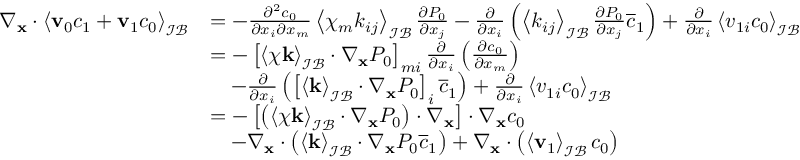<formula> <loc_0><loc_0><loc_500><loc_500>\begin{array} { r l } { \nabla _ { \mathbf x } \cdot \left \langle \mathbf v _ { 0 } c _ { 1 } + \mathbf v _ { 1 } c _ { 0 } \right \rangle _ { \mathcal { I B } } } & { = - \frac { \partial ^ { 2 } c _ { 0 } } { \partial x _ { i } \partial x _ { m } } \left \langle \chi _ { m } k _ { i j } \right \rangle _ { \mathcal { I B } } \frac { \partial P _ { 0 } } { \partial x _ { j } } - \frac { \partial } { \partial x _ { i } } \left ( \left \langle k _ { i j } \right \rangle _ { \mathcal { I B } } \frac { \partial P _ { 0 } } { \partial x _ { j } } \overline { c } _ { 1 } \right ) + \frac { \partial } { \partial x _ { i } } \left \langle v _ { 1 i } c _ { 0 } \right \rangle _ { \mathcal { I B } } } \\ & { = - \left [ \left \langle \boldsymbol \chi \mathbf k \right \rangle _ { \mathcal { I B } } \cdot \nabla _ { \mathbf x } P _ { 0 } \right ] _ { m i } \frac { \partial } { \partial x _ { i } } \left ( \frac { \partial c _ { 0 } } { \partial x _ { m } } \right ) } \\ & { \quad - \frac { \partial } { \partial x _ { i } } \left ( \left [ \left \langle \mathbf k \right \rangle _ { \mathcal { I B } } \cdot \nabla _ { \mathbf x } P _ { 0 } \right ] _ { i } \overline { c } _ { 1 } \right ) + \frac { \partial } { \partial x _ { i } } \left \langle v _ { 1 i } c _ { 0 } \right \rangle _ { \mathcal { I B } } } \\ & { = - \left [ \left ( \left \langle \boldsymbol \chi \mathbf k \right \rangle _ { \mathcal { I B } } \cdot \nabla _ { \mathbf x } P _ { 0 } \right ) \cdot \nabla _ { \mathbf x } \right ] \cdot \nabla _ { \mathbf x } c _ { 0 } } \\ & { \quad - \nabla _ { \mathbf x } \cdot \left ( \left \langle \mathbf k \right \rangle _ { \mathcal { I B } } \cdot \nabla _ { \mathbf x } P _ { 0 } \overline { c } _ { 1 } \right ) + \nabla _ { \mathbf x } \cdot \left ( \left \langle \mathbf v _ { 1 } \right \rangle _ { \mathcal { I B } } c _ { 0 } \right ) } \end{array}</formula> 